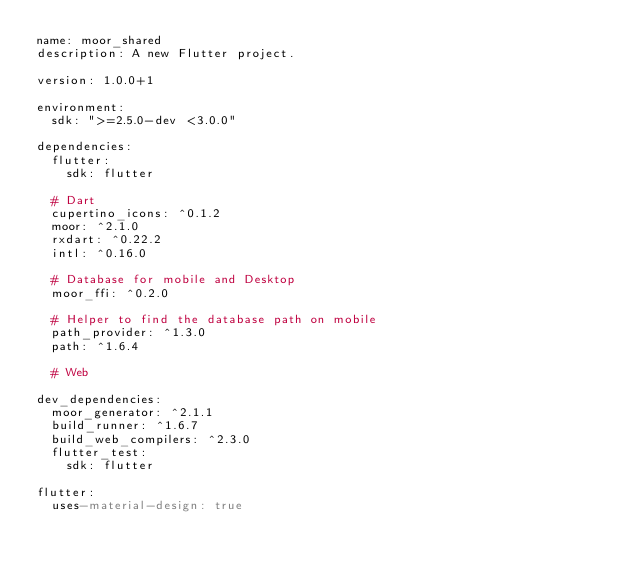<code> <loc_0><loc_0><loc_500><loc_500><_YAML_>name: moor_shared
description: A new Flutter project.

version: 1.0.0+1

environment:
  sdk: ">=2.5.0-dev <3.0.0"

dependencies:
  flutter:
    sdk: flutter
  
  # Dart
  cupertino_icons: ^0.1.2
  moor: ^2.1.0
  rxdart: ^0.22.2
  intl: ^0.16.0

  # Database for mobile and Desktop
  moor_ffi: ^0.2.0
  
  # Helper to find the database path on mobile
  path_provider: ^1.3.0
  path: ^1.6.4

  # Web

dev_dependencies:
  moor_generator: ^2.1.1
  build_runner: ^1.6.7
  build_web_compilers: ^2.3.0
  flutter_test:
    sdk: flutter

flutter:
  uses-material-design: true
</code> 